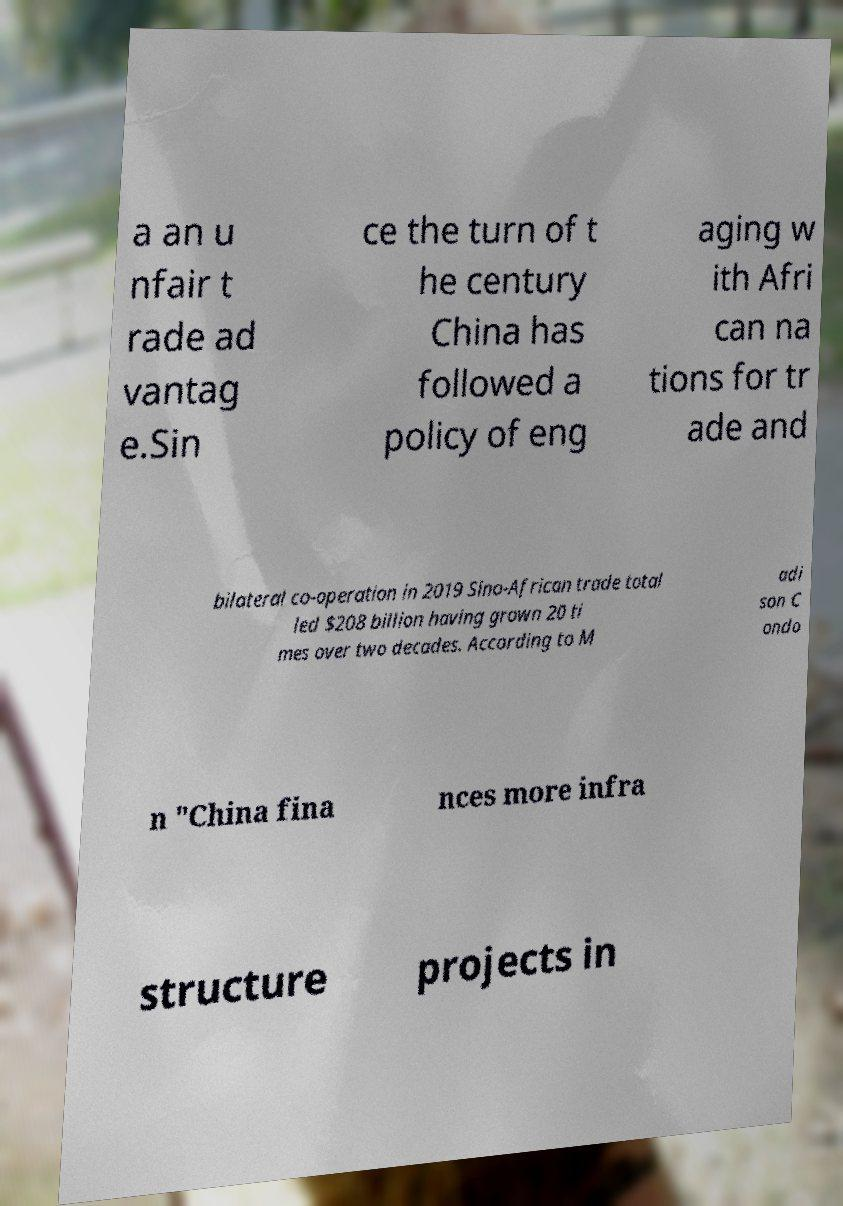Could you extract and type out the text from this image? a an u nfair t rade ad vantag e.Sin ce the turn of t he century China has followed a policy of eng aging w ith Afri can na tions for tr ade and bilateral co-operation in 2019 Sino-African trade total led $208 billion having grown 20 ti mes over two decades. According to M adi son C ondo n "China fina nces more infra structure projects in 